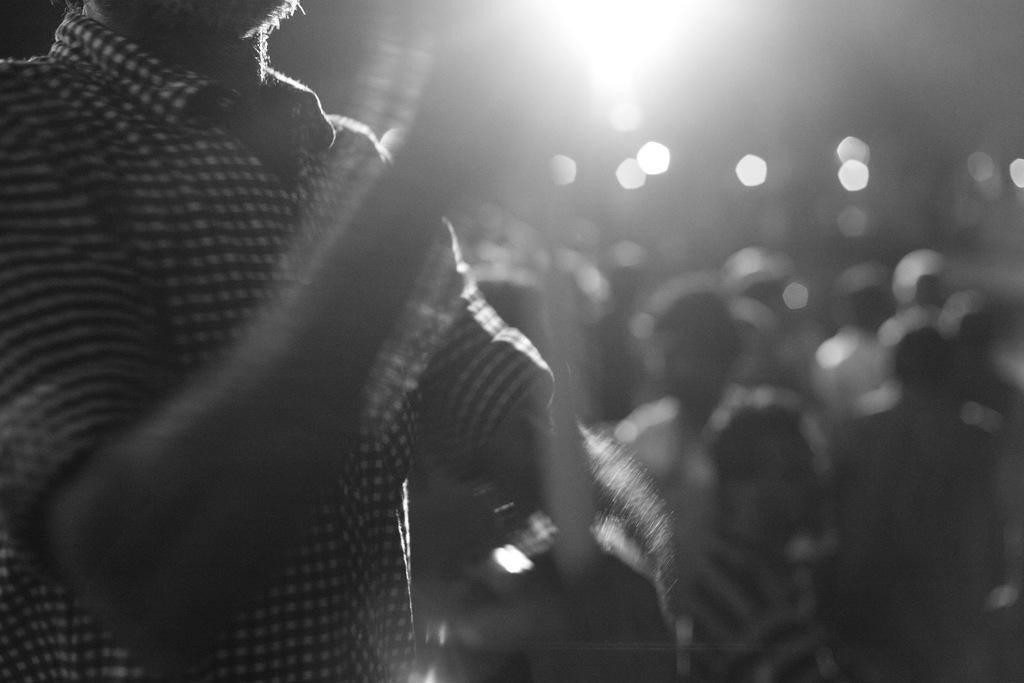What is the color scheme of the image? The image is black and white. What can be seen in the image? There are people in the image. How many children are holding a bottle and a seed in the image? There are no children, bottles, or seeds present in the image, as it is a black and white image with people as the main subject. 